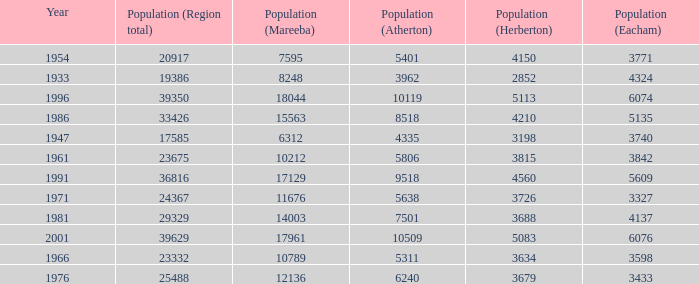What was the smallest population figure for Mareeba? 6312.0. 